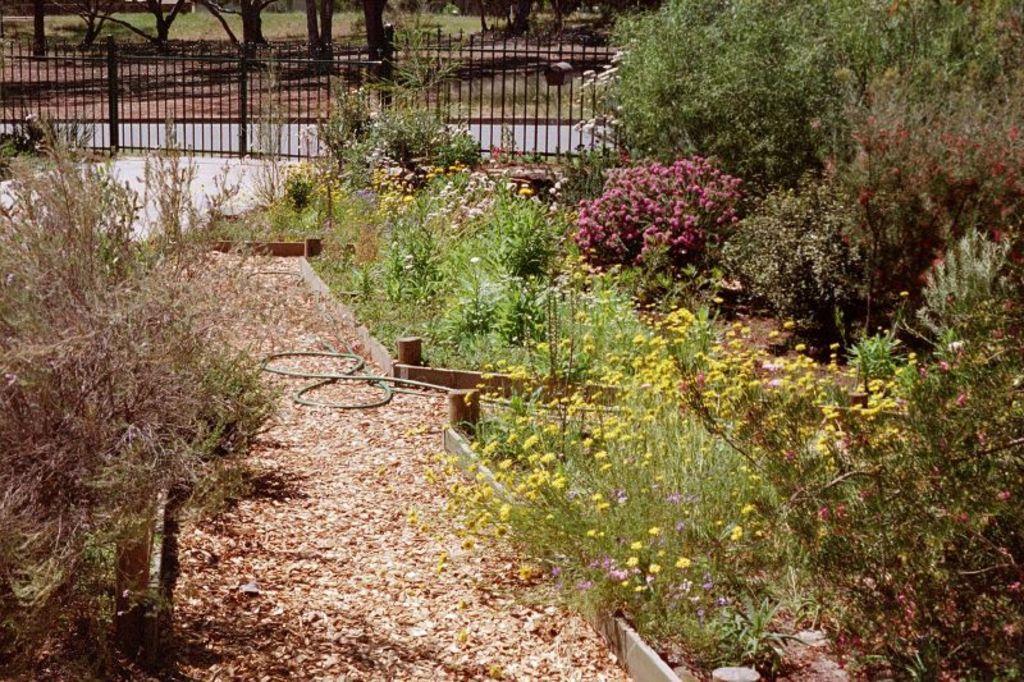Could you give a brief overview of what you see in this image? This image is taken outdoors. At the bottom of the image there is a ground with dry leaves on it. In the background there are a few trees on the ground and there is a railing. On the left and right sides of the image there are many trees and plants on the ground. 